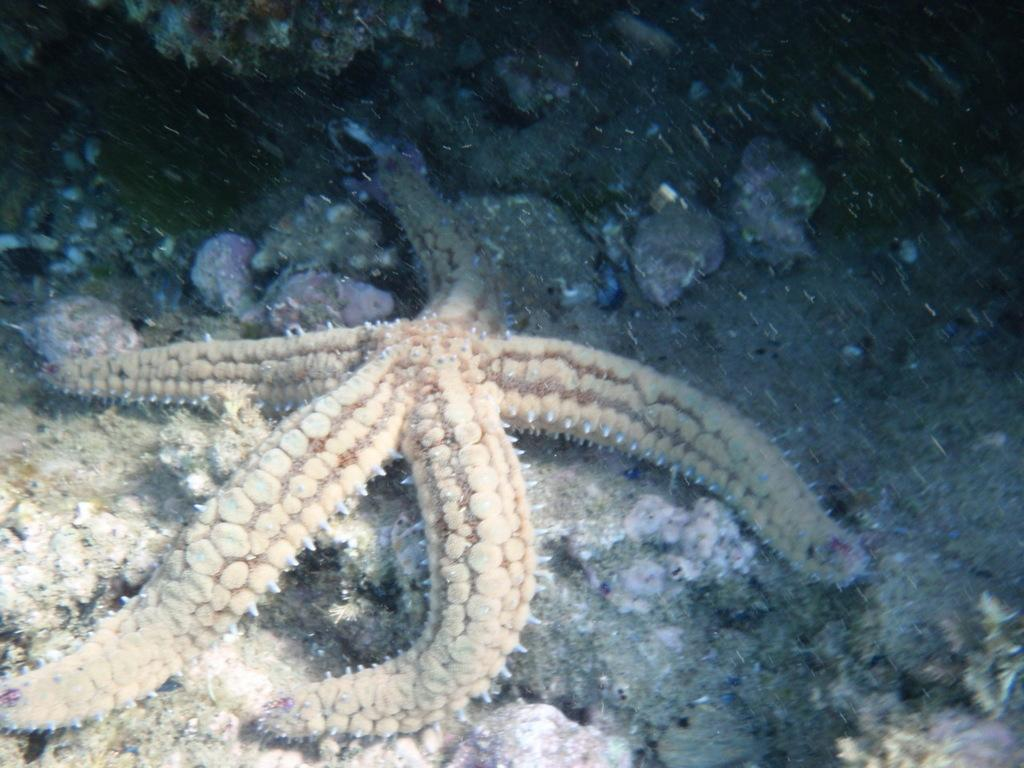What type of sea creature is in the image? There is a starfish in the image. Where is the starfish located? The starfish is on the ground. Is the starfish driving a car in the image? No, the starfish is not driving a car in the image. Starfish do not have the ability to drive cars. 